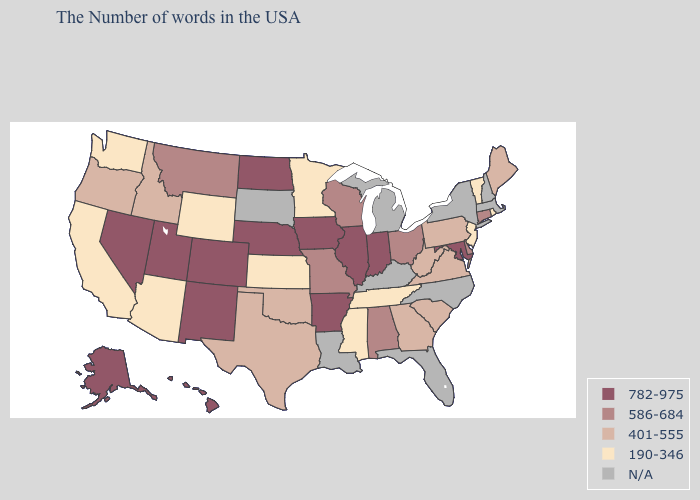What is the value of Rhode Island?
Give a very brief answer. 190-346. What is the highest value in states that border Washington?
Keep it brief. 401-555. What is the value of Arizona?
Quick response, please. 190-346. What is the lowest value in the MidWest?
Quick response, please. 190-346. What is the highest value in states that border Oklahoma?
Keep it brief. 782-975. Name the states that have a value in the range 782-975?
Write a very short answer. Maryland, Indiana, Illinois, Arkansas, Iowa, Nebraska, North Dakota, Colorado, New Mexico, Utah, Nevada, Alaska, Hawaii. Does Wisconsin have the lowest value in the MidWest?
Be succinct. No. Name the states that have a value in the range 586-684?
Quick response, please. Connecticut, Delaware, Ohio, Alabama, Wisconsin, Missouri, Montana. What is the highest value in the USA?
Answer briefly. 782-975. Which states hav the highest value in the MidWest?
Be succinct. Indiana, Illinois, Iowa, Nebraska, North Dakota. What is the highest value in the USA?
Give a very brief answer. 782-975. What is the lowest value in the West?
Give a very brief answer. 190-346. Does Hawaii have the lowest value in the West?
Be succinct. No. What is the lowest value in the West?
Give a very brief answer. 190-346. Does Kansas have the lowest value in the MidWest?
Keep it brief. Yes. 